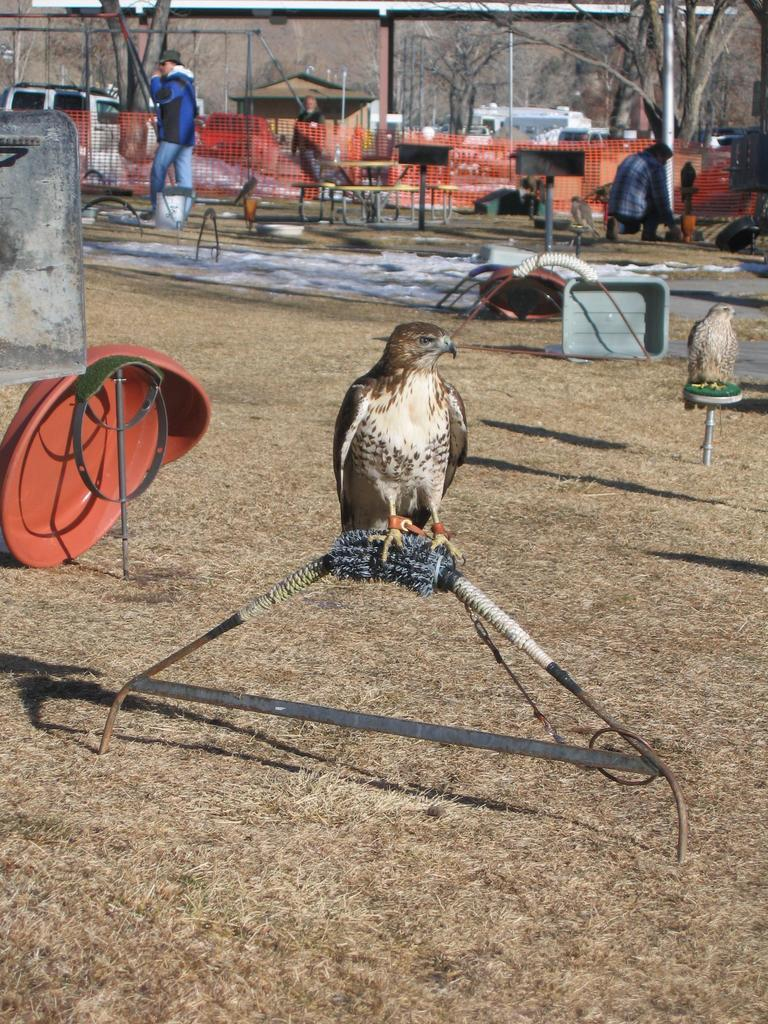What type of animals can be seen in the image? Birds can be seen in the image. What type of vegetation is present in the image? There are trees in the image. Are there any human figures in the image? Yes, there are people in the image. Can you describe the overall scene in the image? The image contains birds, trees, and people, along with many objects. What type of feather can be seen on the dog in the image? There is no dog present in the image, so there is no feather to be seen. 